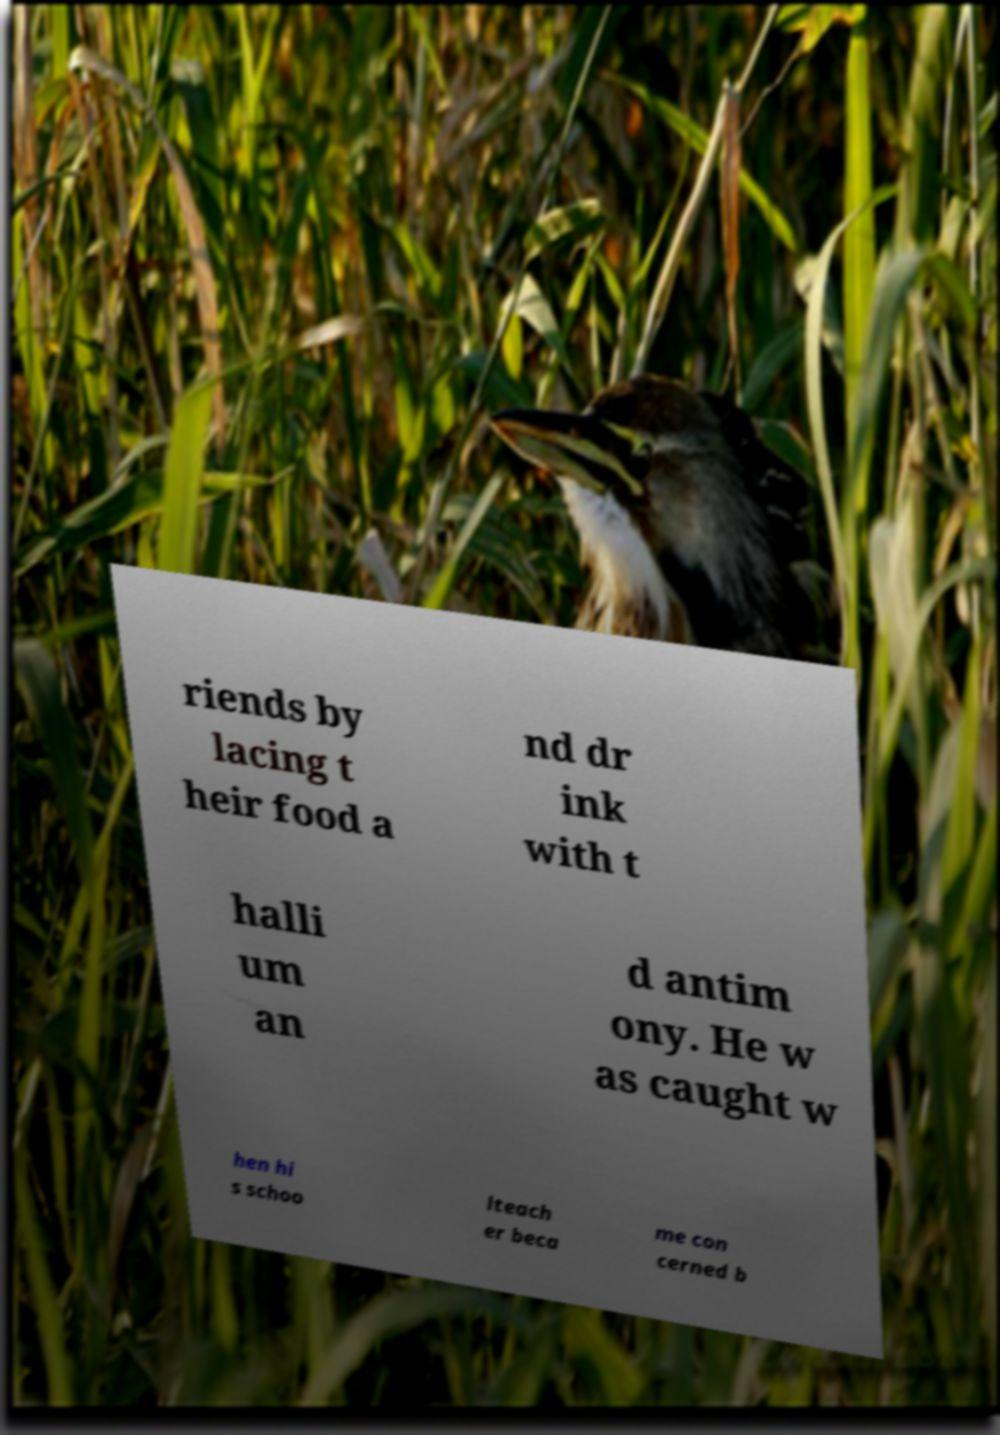Please identify and transcribe the text found in this image. riends by lacing t heir food a nd dr ink with t halli um an d antim ony. He w as caught w hen hi s schoo lteach er beca me con cerned b 